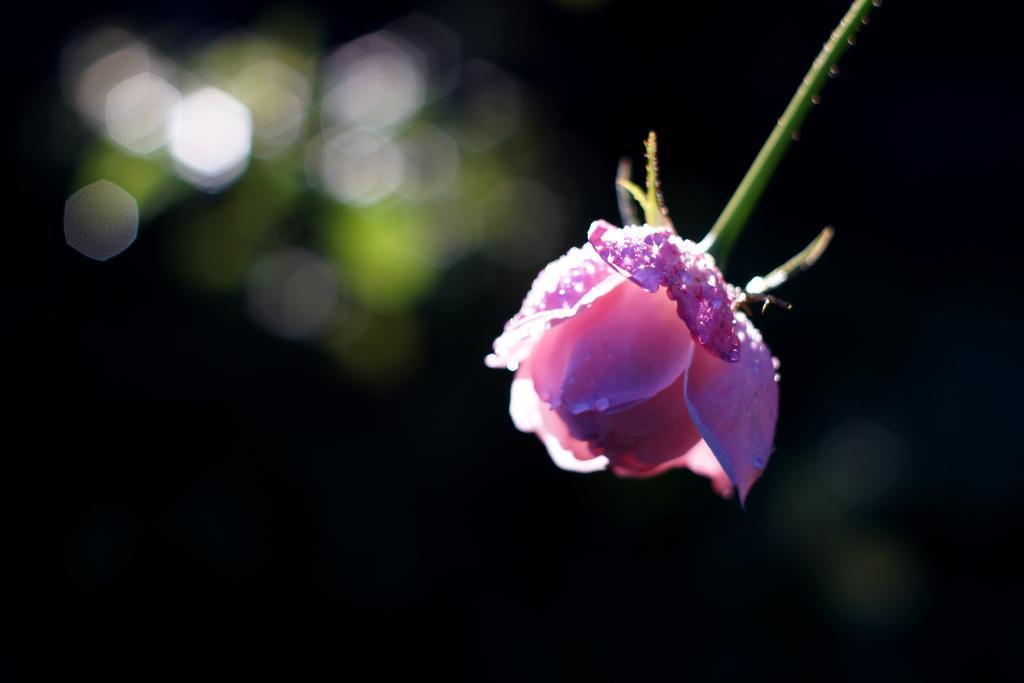Describe this image in one or two sentences. In this image in the front there is a flower and the background is blurry. 